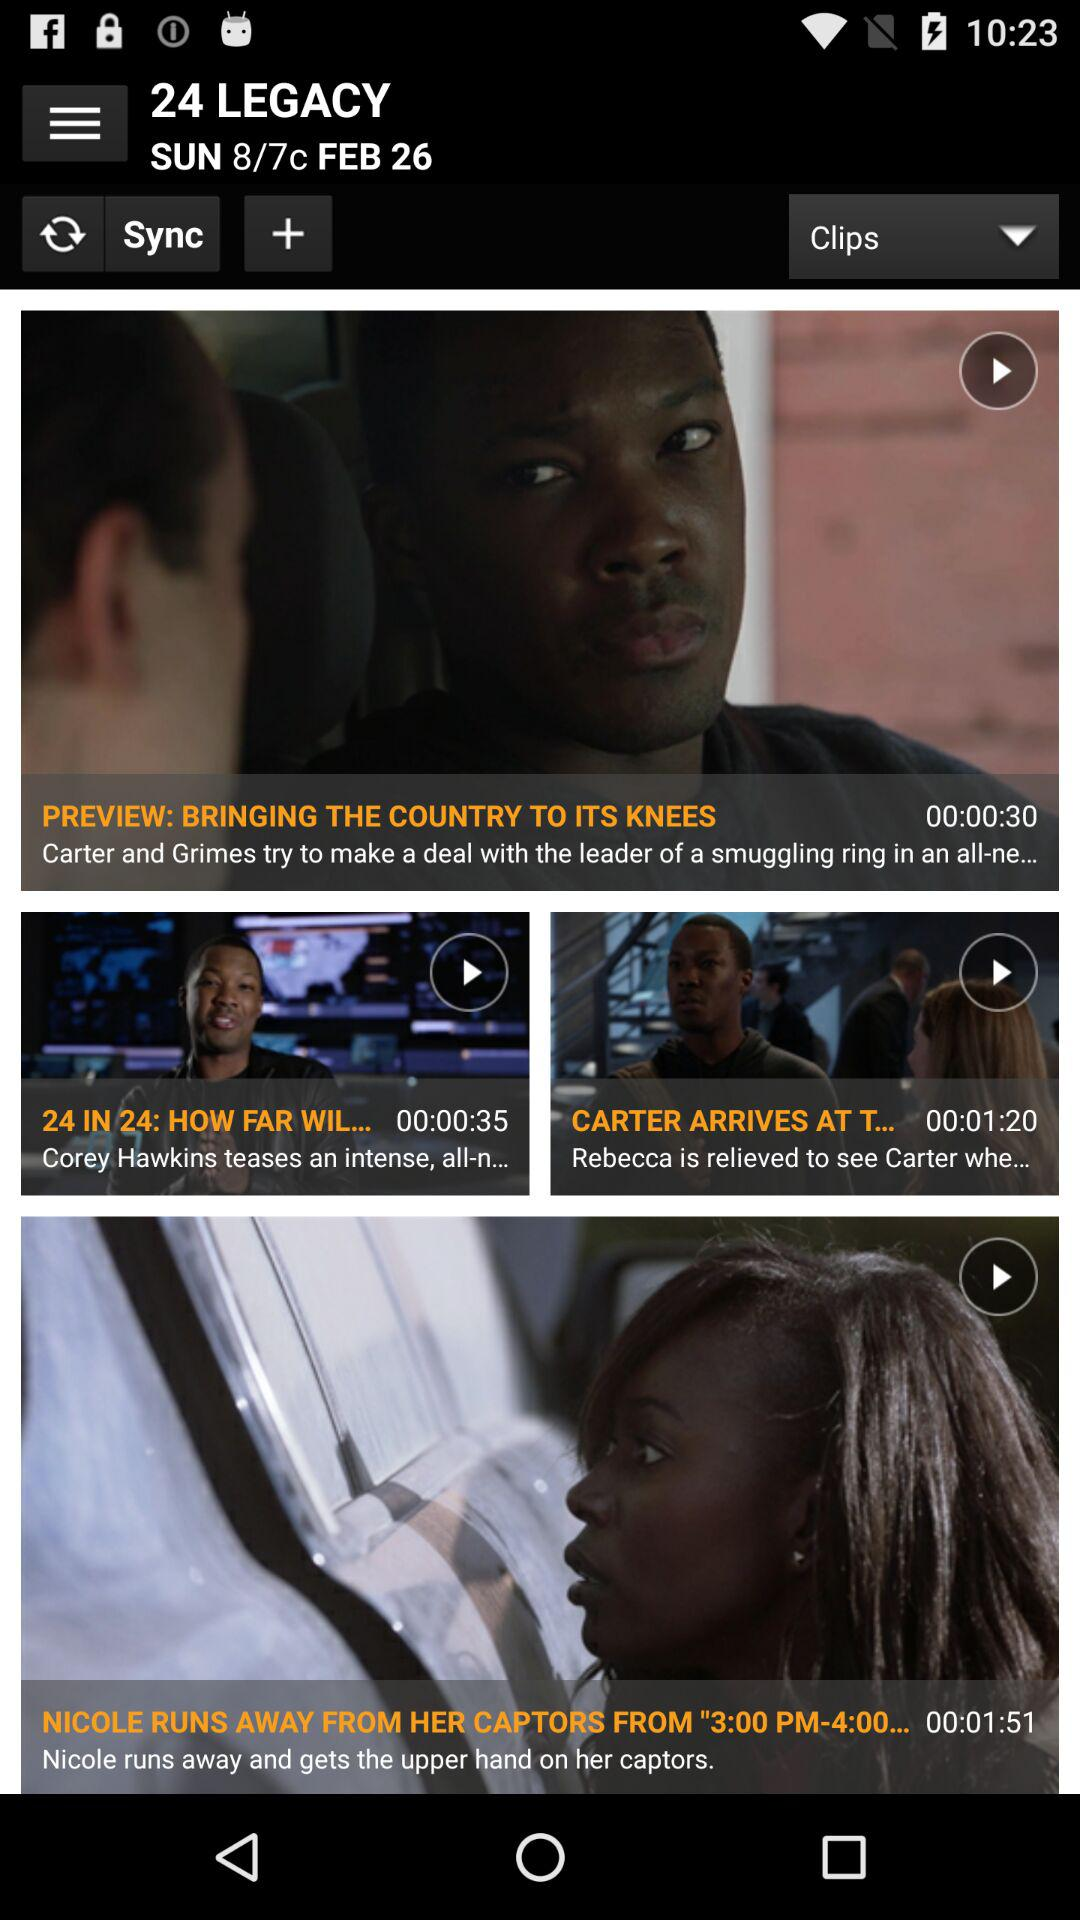What is the duration of "BRINGING THE COUNTRY TO ITS KNEES"? The duration is 30 seconds. 